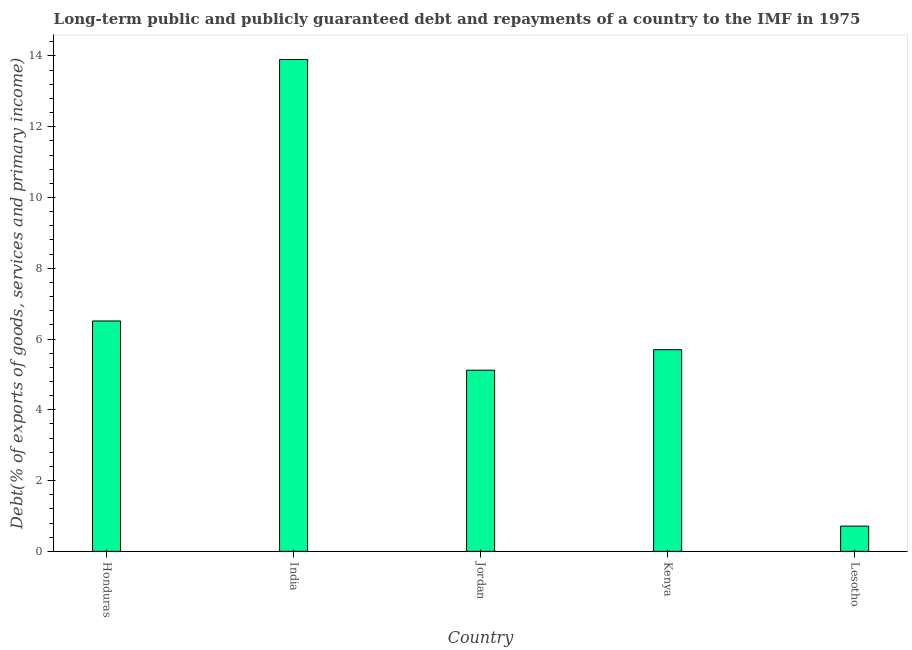Does the graph contain any zero values?
Give a very brief answer. No. What is the title of the graph?
Offer a terse response. Long-term public and publicly guaranteed debt and repayments of a country to the IMF in 1975. What is the label or title of the Y-axis?
Provide a succinct answer. Debt(% of exports of goods, services and primary income). What is the debt service in India?
Offer a very short reply. 13.9. Across all countries, what is the maximum debt service?
Make the answer very short. 13.9. Across all countries, what is the minimum debt service?
Keep it short and to the point. 0.71. In which country was the debt service minimum?
Keep it short and to the point. Lesotho. What is the sum of the debt service?
Give a very brief answer. 31.95. What is the difference between the debt service in Honduras and India?
Provide a short and direct response. -7.39. What is the average debt service per country?
Ensure brevity in your answer.  6.39. What is the median debt service?
Keep it short and to the point. 5.7. In how many countries, is the debt service greater than 1.2 %?
Offer a terse response. 4. What is the ratio of the debt service in Jordan to that in Kenya?
Ensure brevity in your answer.  0.9. What is the difference between the highest and the second highest debt service?
Your answer should be compact. 7.39. Is the sum of the debt service in Kenya and Lesotho greater than the maximum debt service across all countries?
Provide a succinct answer. No. What is the difference between the highest and the lowest debt service?
Offer a very short reply. 13.19. In how many countries, is the debt service greater than the average debt service taken over all countries?
Keep it short and to the point. 2. What is the difference between two consecutive major ticks on the Y-axis?
Give a very brief answer. 2. Are the values on the major ticks of Y-axis written in scientific E-notation?
Offer a very short reply. No. What is the Debt(% of exports of goods, services and primary income) of Honduras?
Offer a terse response. 6.51. What is the Debt(% of exports of goods, services and primary income) in India?
Provide a succinct answer. 13.9. What is the Debt(% of exports of goods, services and primary income) of Jordan?
Provide a succinct answer. 5.12. What is the Debt(% of exports of goods, services and primary income) in Kenya?
Your answer should be very brief. 5.7. What is the Debt(% of exports of goods, services and primary income) of Lesotho?
Provide a succinct answer. 0.71. What is the difference between the Debt(% of exports of goods, services and primary income) in Honduras and India?
Make the answer very short. -7.39. What is the difference between the Debt(% of exports of goods, services and primary income) in Honduras and Jordan?
Keep it short and to the point. 1.39. What is the difference between the Debt(% of exports of goods, services and primary income) in Honduras and Kenya?
Offer a terse response. 0.81. What is the difference between the Debt(% of exports of goods, services and primary income) in Honduras and Lesotho?
Ensure brevity in your answer.  5.8. What is the difference between the Debt(% of exports of goods, services and primary income) in India and Jordan?
Provide a short and direct response. 8.78. What is the difference between the Debt(% of exports of goods, services and primary income) in India and Kenya?
Provide a short and direct response. 8.2. What is the difference between the Debt(% of exports of goods, services and primary income) in India and Lesotho?
Your answer should be very brief. 13.19. What is the difference between the Debt(% of exports of goods, services and primary income) in Jordan and Kenya?
Give a very brief answer. -0.58. What is the difference between the Debt(% of exports of goods, services and primary income) in Jordan and Lesotho?
Your answer should be very brief. 4.41. What is the difference between the Debt(% of exports of goods, services and primary income) in Kenya and Lesotho?
Offer a terse response. 4.99. What is the ratio of the Debt(% of exports of goods, services and primary income) in Honduras to that in India?
Keep it short and to the point. 0.47. What is the ratio of the Debt(% of exports of goods, services and primary income) in Honduras to that in Jordan?
Keep it short and to the point. 1.27. What is the ratio of the Debt(% of exports of goods, services and primary income) in Honduras to that in Kenya?
Provide a succinct answer. 1.14. What is the ratio of the Debt(% of exports of goods, services and primary income) in Honduras to that in Lesotho?
Your answer should be very brief. 9.12. What is the ratio of the Debt(% of exports of goods, services and primary income) in India to that in Jordan?
Offer a terse response. 2.71. What is the ratio of the Debt(% of exports of goods, services and primary income) in India to that in Kenya?
Keep it short and to the point. 2.44. What is the ratio of the Debt(% of exports of goods, services and primary income) in India to that in Lesotho?
Offer a very short reply. 19.47. What is the ratio of the Debt(% of exports of goods, services and primary income) in Jordan to that in Kenya?
Your answer should be very brief. 0.9. What is the ratio of the Debt(% of exports of goods, services and primary income) in Jordan to that in Lesotho?
Your answer should be compact. 7.17. What is the ratio of the Debt(% of exports of goods, services and primary income) in Kenya to that in Lesotho?
Provide a short and direct response. 7.98. 